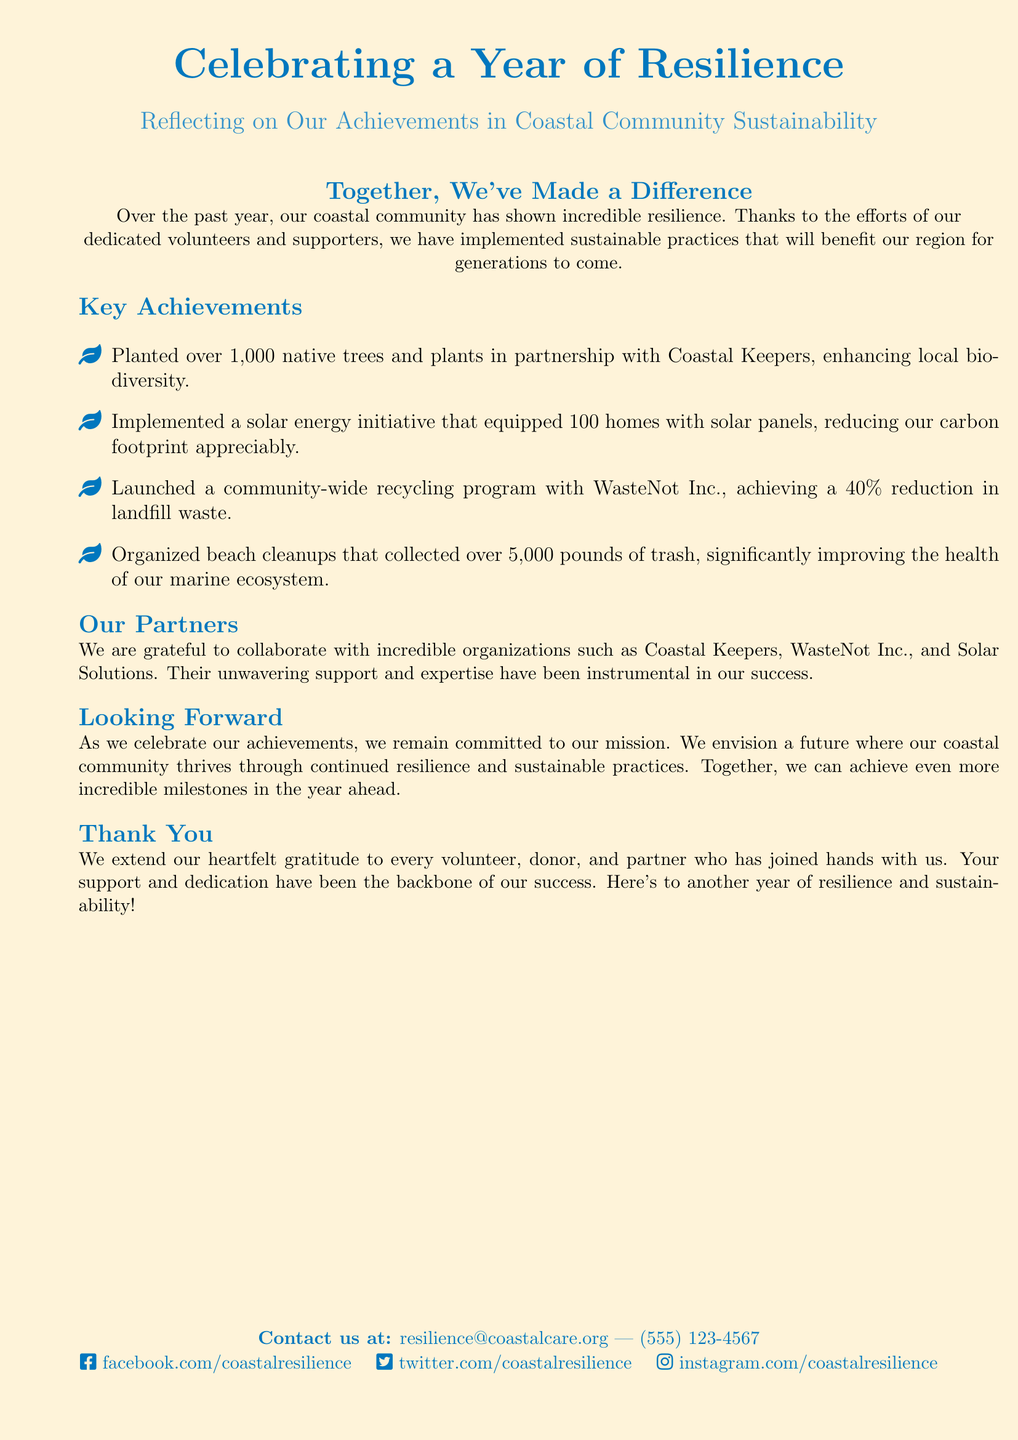What is the main theme of the card? The main theme of the card focuses on celebrating a year of achievements related to resilience and sustainability in coastal communities.
Answer: Celebrating a Year of Resilience How many native trees and plants were planted? The document states that over 1,000 native trees and plants were planted in collaboration with Coastal Keepers.
Answer: Over 1,000 Which organization is mentioned for the solar energy initiative? The solar energy initiative is associated with Solar Solutions, as mentioned in the achievements section of the document.
Answer: Solar Solutions What percentage reduction in landfill waste was achieved? The document highlights that the community-wide recycling program achieved a 40% reduction in landfill waste.
Answer: 40% Who extended gratitude to volunteers and partners? The card expresses thanks to every volunteer, donor, and partner for their support and dedication.
Answer: We What is one of the future commitments mentioned? The document indicates a commitment to continue supporting the mission for coastal community resilience and sustainable practices.
Answer: Continued resilience and sustainable practices What type of imagery is used on the card? The card features coastal imagery and sustainability icons to reflect the theme of resilience and environmental care.
Answer: Coastal imagery and sustainability icons What is the contact email provided in the card? The contact email listed in the card for inquiries is resilience@coastalcare.org.
Answer: resilience@coastalcare.org 